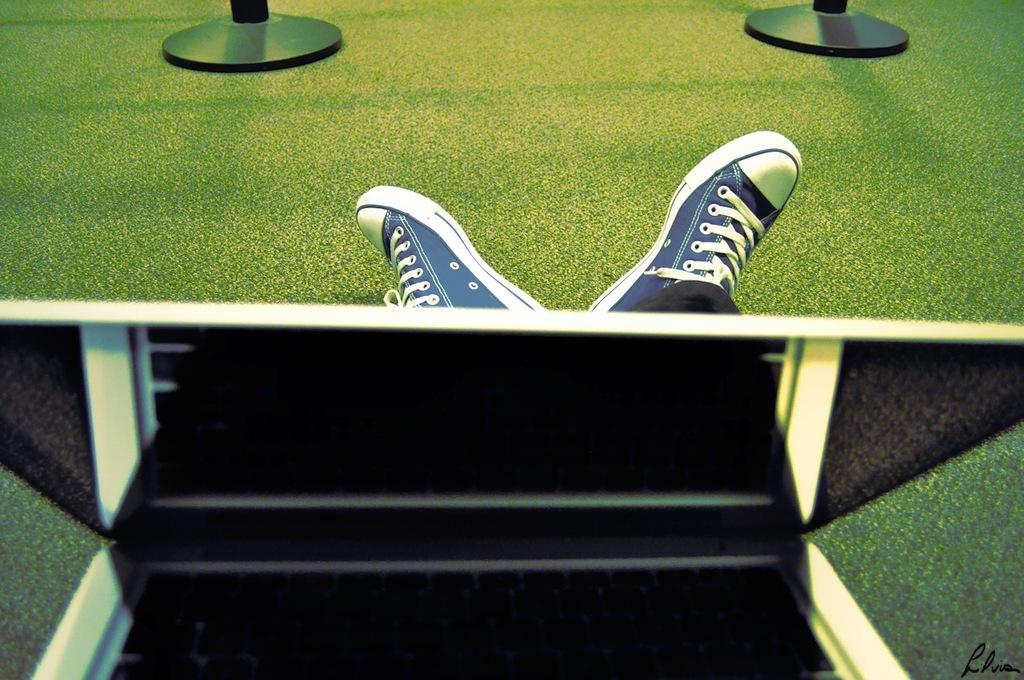What is the main subject in the foreground of the image? There is an object in the foreground of the image. Can you describe any human or animal features in the image? Yes, there are legs visible in the image. What type of terrain is the legs standing on? The legs are on a grassland. What can be seen at the top of the image? There appear to be poles at the top of the image. What type of patch is being sewn onto the body in the image? There is no body or patch present in the image; it only features an object, legs on a grassland, and poles at the top. 